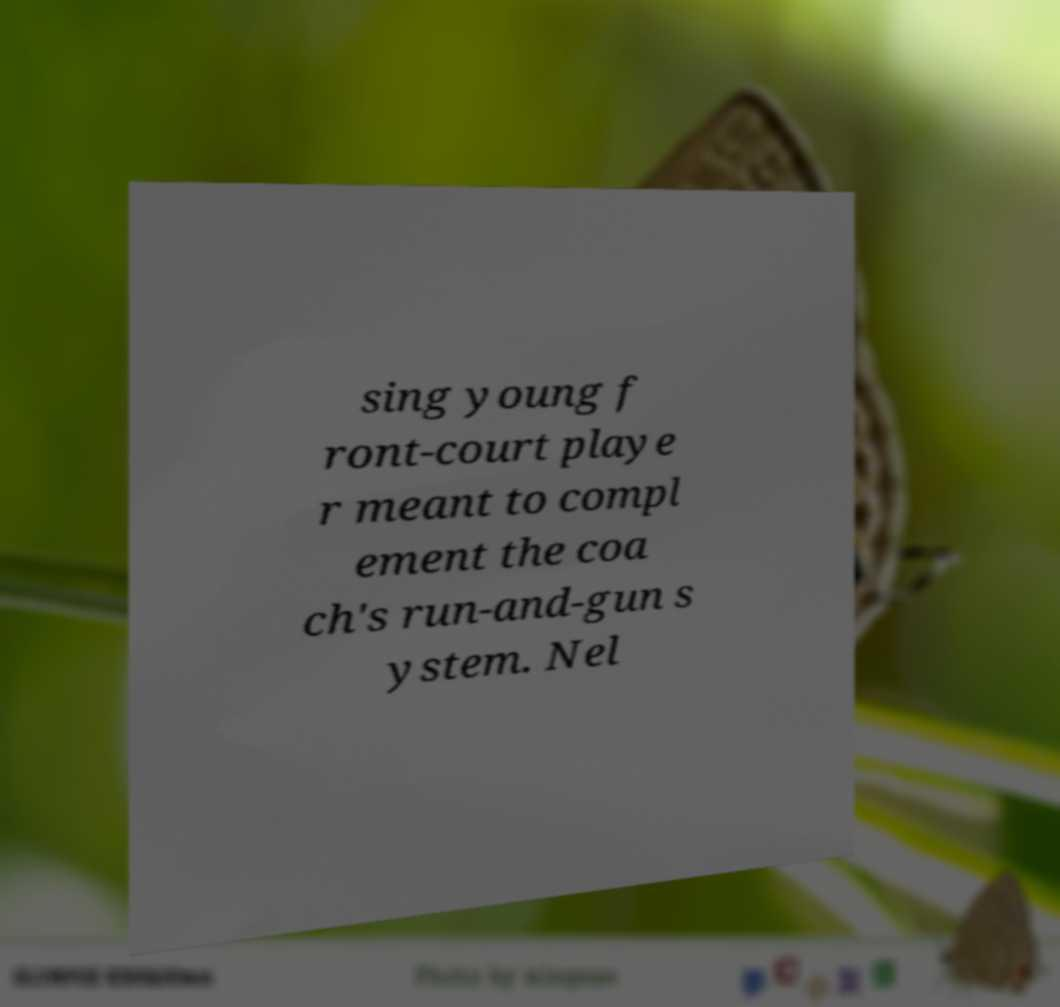For documentation purposes, I need the text within this image transcribed. Could you provide that? sing young f ront-court playe r meant to compl ement the coa ch's run-and-gun s ystem. Nel 